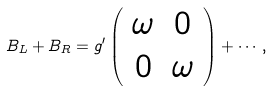Convert formula to latex. <formula><loc_0><loc_0><loc_500><loc_500>B _ { L } + B _ { R } = g ^ { \prime } \left ( \begin{array} { c c } \omega & 0 \\ 0 & \omega \end{array} \right ) + \cdots \, ,</formula> 